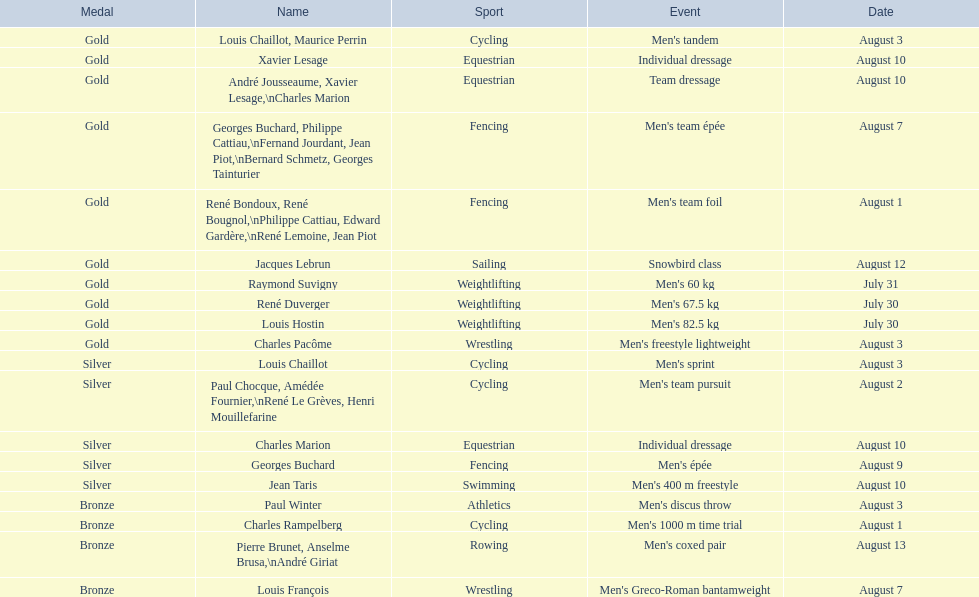Louis chaillot won a gold medal for cycling and a silver medal for what sport? Cycling. 